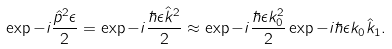<formula> <loc_0><loc_0><loc_500><loc_500>\exp { - i \frac { \hat { p } ^ { 2 } \epsilon } { 2 } } = \exp { - i \frac { \hbar { \epsilon } \hat { k } ^ { 2 } } { 2 } } \approx \exp { - i \frac { \hbar { \epsilon } k _ { 0 } ^ { 2 } } { 2 } } \exp { - i \hbar { \epsilon } k _ { 0 } \hat { k } _ { 1 } } .</formula> 